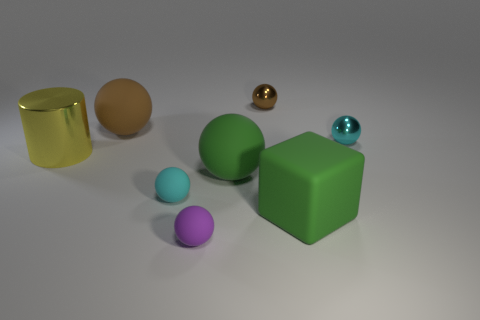Subtract all tiny cyan spheres. How many spheres are left? 4 Subtract all purple cylinders. How many brown balls are left? 2 Add 1 gray cylinders. How many objects exist? 9 Subtract all green spheres. How many spheres are left? 5 Subtract all cyan balls. Subtract all gray blocks. How many balls are left? 4 Subtract all cyan spheres. Subtract all small cyan spheres. How many objects are left? 4 Add 1 matte blocks. How many matte blocks are left? 2 Add 5 tiny yellow matte cylinders. How many tiny yellow matte cylinders exist? 5 Subtract 1 yellow cylinders. How many objects are left? 7 Subtract all spheres. How many objects are left? 2 